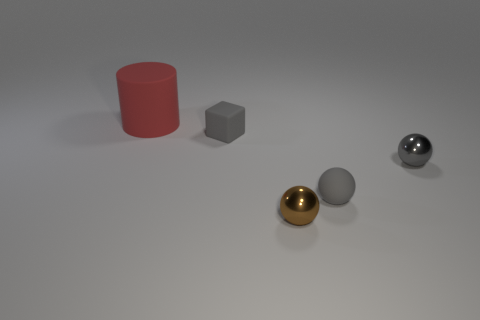Is there any other thing that is the same size as the cylinder?
Offer a terse response. No. There is a shiny sphere that is to the right of the brown metallic object; is its size the same as the thing that is left of the gray cube?
Your response must be concise. No. What number of objects are either things that are to the right of the large matte object or large red cylinders?
Keep it short and to the point. 5. What is the material of the small brown thing?
Your response must be concise. Metal. Do the matte sphere and the red matte thing have the same size?
Make the answer very short. No. What number of cylinders are either brown things or small rubber things?
Ensure brevity in your answer.  0. There is a shiny sphere that is behind the gray matte thing in front of the gray block; what color is it?
Offer a very short reply. Gray. Is the number of small brown metal objects behind the large matte cylinder less than the number of tiny rubber balls to the right of the tiny gray rubber ball?
Provide a succinct answer. No. There is a cylinder; is its size the same as the shiny sphere that is right of the brown thing?
Make the answer very short. No. What is the shape of the rubber thing that is on the left side of the tiny brown ball and in front of the big red thing?
Give a very brief answer. Cube. 